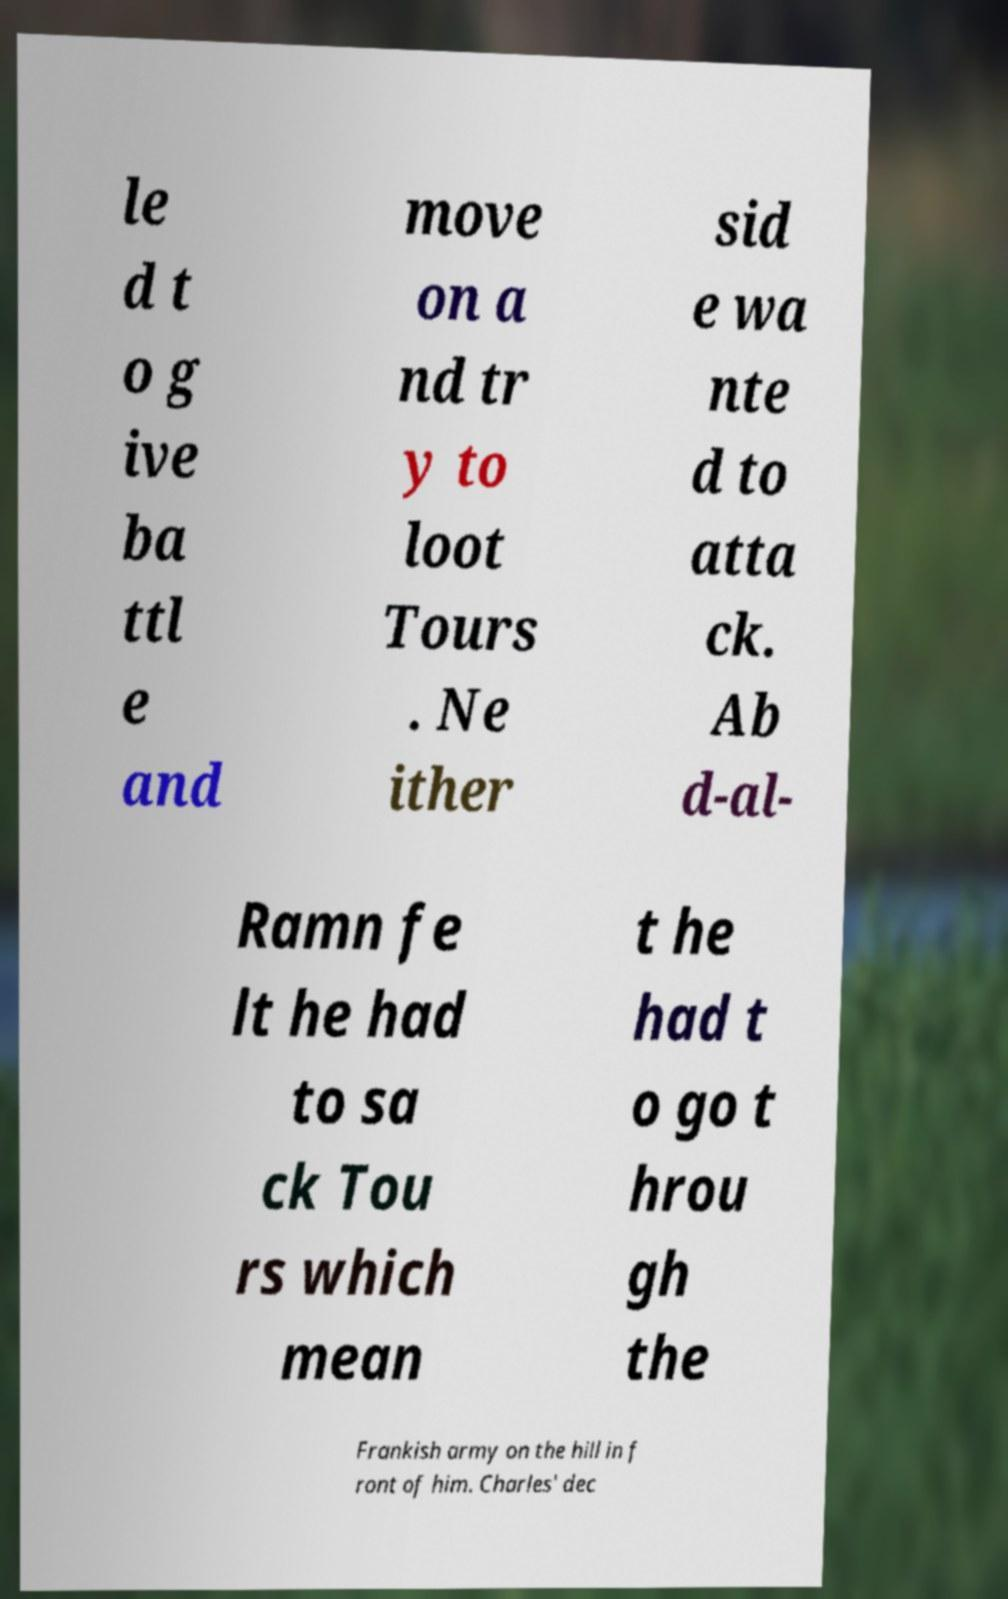What messages or text are displayed in this image? I need them in a readable, typed format. le d t o g ive ba ttl e and move on a nd tr y to loot Tours . Ne ither sid e wa nte d to atta ck. Ab d-al- Ramn fe lt he had to sa ck Tou rs which mean t he had t o go t hrou gh the Frankish army on the hill in f ront of him. Charles' dec 